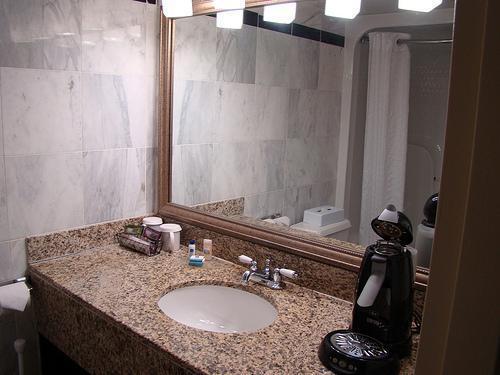How many taps are there?
Give a very brief answer. 2. 